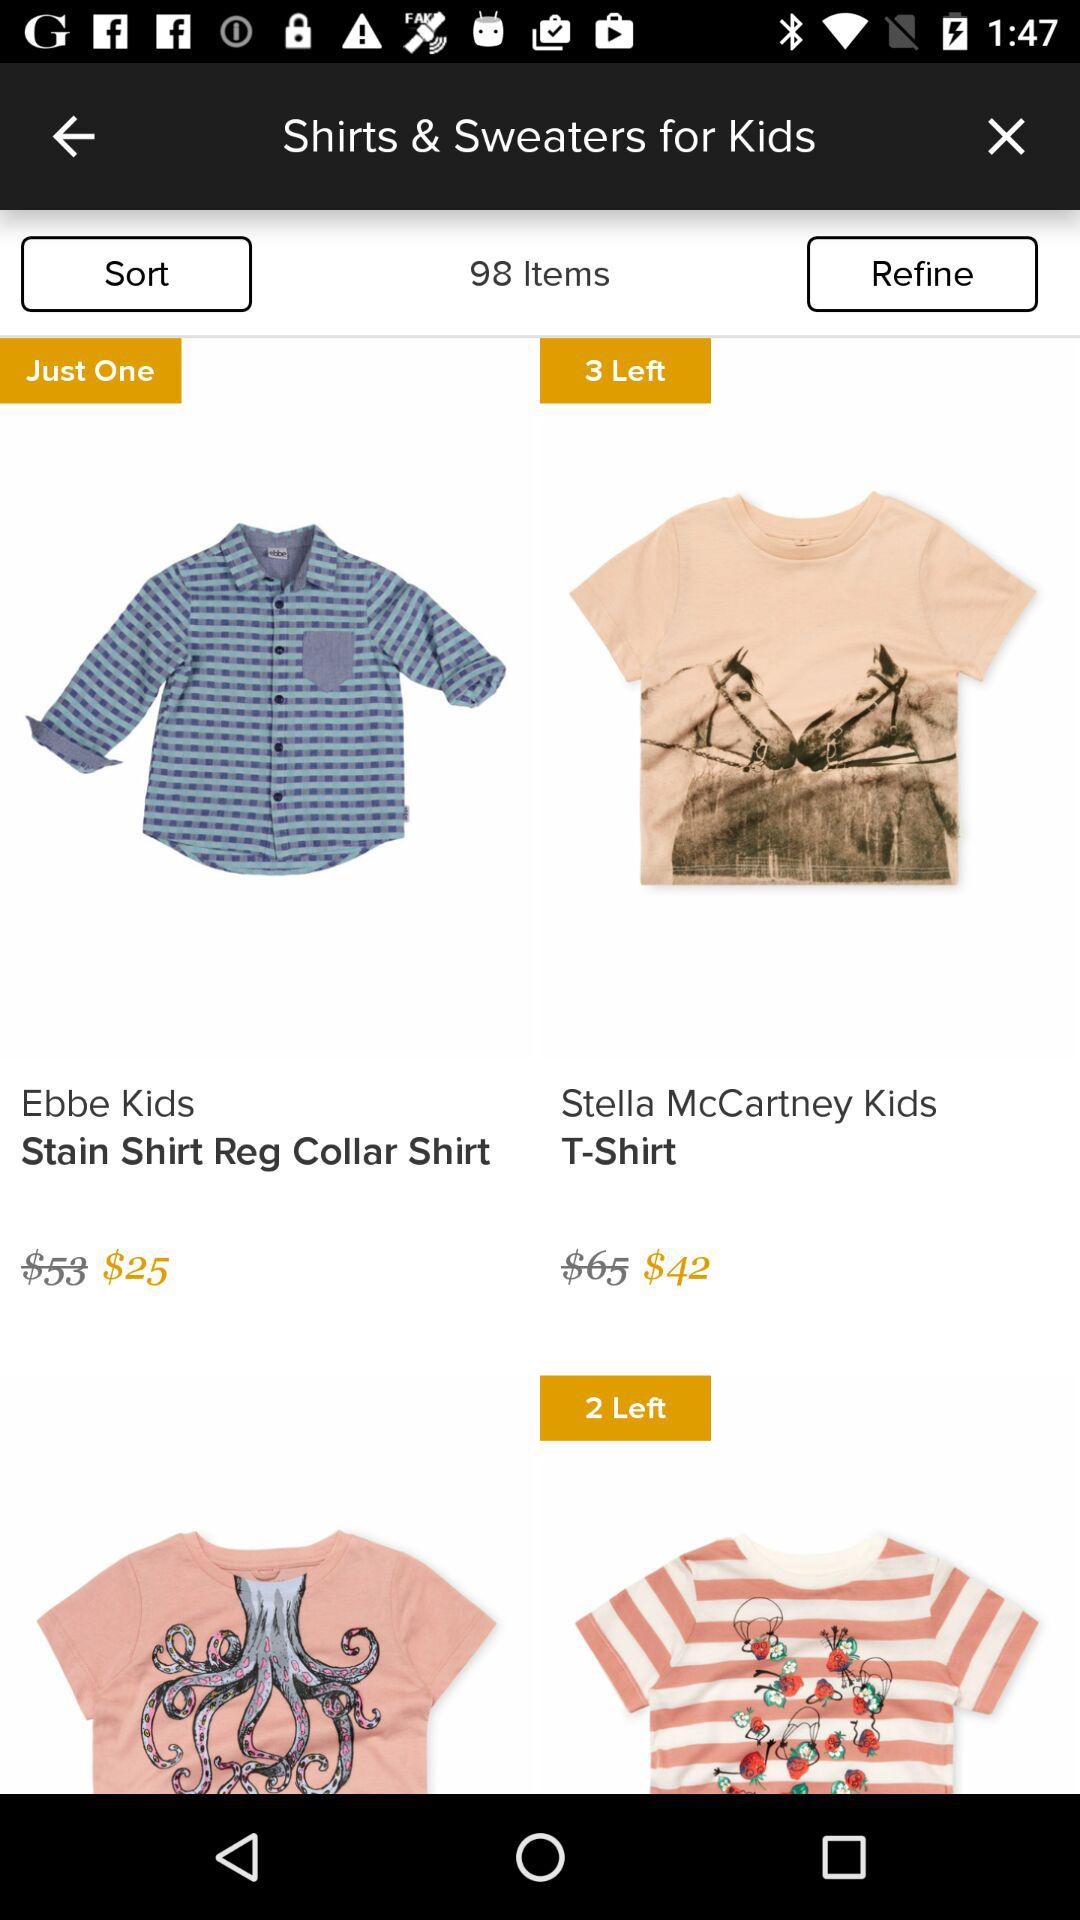What was the original price of Stella McCartney's Kids T-shirt? The original price was $65. 